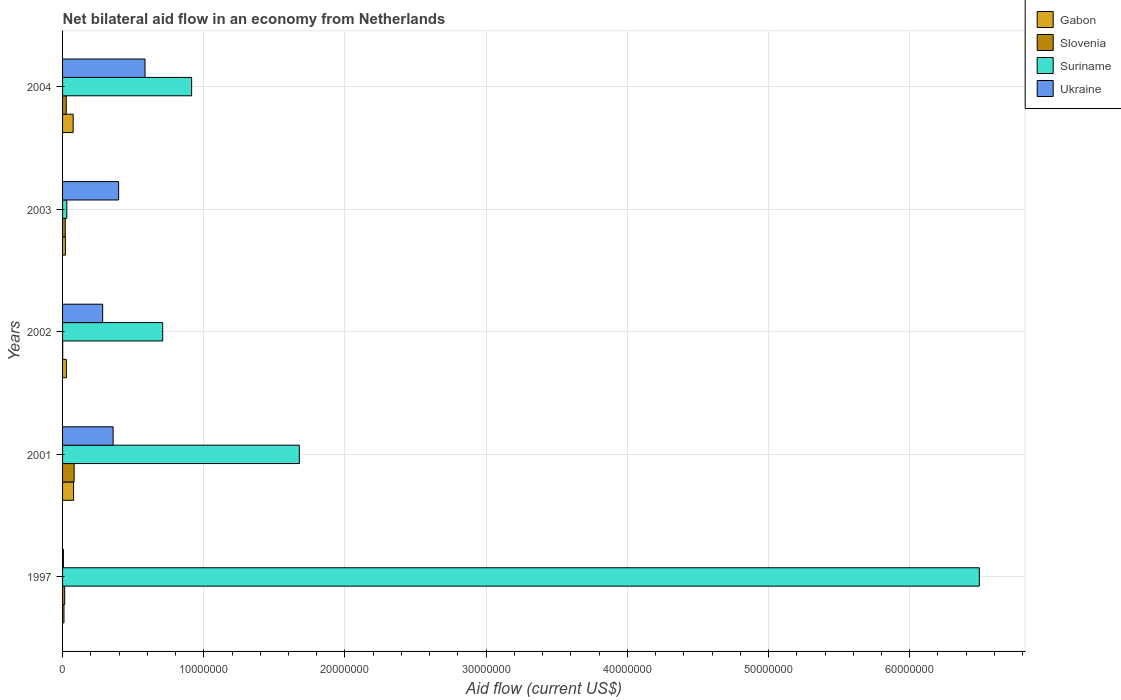How many groups of bars are there?
Your answer should be very brief. 5. Are the number of bars per tick equal to the number of legend labels?
Offer a terse response. Yes. How many bars are there on the 4th tick from the top?
Ensure brevity in your answer.  4. How many bars are there on the 2nd tick from the bottom?
Your answer should be very brief. 4. What is the label of the 3rd group of bars from the top?
Keep it short and to the point. 2002. What is the net bilateral aid flow in Gabon in 2001?
Provide a succinct answer. 7.80e+05. Across all years, what is the maximum net bilateral aid flow in Gabon?
Provide a succinct answer. 7.80e+05. In which year was the net bilateral aid flow in Slovenia minimum?
Keep it short and to the point. 2002. What is the total net bilateral aid flow in Suriname in the graph?
Ensure brevity in your answer.  9.82e+07. What is the difference between the net bilateral aid flow in Suriname in 2003 and that in 2004?
Give a very brief answer. -8.84e+06. What is the difference between the net bilateral aid flow in Gabon in 2004 and the net bilateral aid flow in Ukraine in 2003?
Make the answer very short. -3.22e+06. What is the average net bilateral aid flow in Suriname per year?
Provide a short and direct response. 1.96e+07. In the year 2002, what is the difference between the net bilateral aid flow in Ukraine and net bilateral aid flow in Suriname?
Your answer should be compact. -4.25e+06. What is the ratio of the net bilateral aid flow in Gabon in 2002 to that in 2003?
Make the answer very short. 1.35. Is the net bilateral aid flow in Ukraine in 1997 less than that in 2003?
Keep it short and to the point. Yes. What is the difference between the highest and the second highest net bilateral aid flow in Slovenia?
Your answer should be compact. 5.60e+05. What is the difference between the highest and the lowest net bilateral aid flow in Suriname?
Give a very brief answer. 6.46e+07. Is the sum of the net bilateral aid flow in Slovenia in 2001 and 2002 greater than the maximum net bilateral aid flow in Gabon across all years?
Offer a terse response. Yes. What does the 2nd bar from the top in 2003 represents?
Your response must be concise. Suriname. What does the 2nd bar from the bottom in 2001 represents?
Your answer should be very brief. Slovenia. What is the difference between two consecutive major ticks on the X-axis?
Offer a very short reply. 1.00e+07. Where does the legend appear in the graph?
Offer a very short reply. Top right. How many legend labels are there?
Make the answer very short. 4. How are the legend labels stacked?
Your answer should be compact. Vertical. What is the title of the graph?
Provide a succinct answer. Net bilateral aid flow in an economy from Netherlands. What is the label or title of the X-axis?
Keep it short and to the point. Aid flow (current US$). What is the Aid flow (current US$) in Gabon in 1997?
Provide a short and direct response. 1.00e+05. What is the Aid flow (current US$) in Suriname in 1997?
Keep it short and to the point. 6.49e+07. What is the Aid flow (current US$) of Ukraine in 1997?
Give a very brief answer. 6.00e+04. What is the Aid flow (current US$) of Gabon in 2001?
Your answer should be very brief. 7.80e+05. What is the Aid flow (current US$) in Slovenia in 2001?
Provide a succinct answer. 8.20e+05. What is the Aid flow (current US$) of Suriname in 2001?
Provide a short and direct response. 1.68e+07. What is the Aid flow (current US$) of Ukraine in 2001?
Your answer should be compact. 3.58e+06. What is the Aid flow (current US$) in Suriname in 2002?
Your response must be concise. 7.09e+06. What is the Aid flow (current US$) in Ukraine in 2002?
Give a very brief answer. 2.84e+06. What is the Aid flow (current US$) in Suriname in 2003?
Keep it short and to the point. 3.00e+05. What is the Aid flow (current US$) of Ukraine in 2003?
Ensure brevity in your answer.  3.97e+06. What is the Aid flow (current US$) of Gabon in 2004?
Give a very brief answer. 7.50e+05. What is the Aid flow (current US$) of Suriname in 2004?
Provide a short and direct response. 9.14e+06. What is the Aid flow (current US$) in Ukraine in 2004?
Give a very brief answer. 5.84e+06. Across all years, what is the maximum Aid flow (current US$) of Gabon?
Keep it short and to the point. 7.80e+05. Across all years, what is the maximum Aid flow (current US$) of Slovenia?
Provide a succinct answer. 8.20e+05. Across all years, what is the maximum Aid flow (current US$) in Suriname?
Make the answer very short. 6.49e+07. Across all years, what is the maximum Aid flow (current US$) of Ukraine?
Offer a terse response. 5.84e+06. Across all years, what is the minimum Aid flow (current US$) of Slovenia?
Provide a short and direct response. 10000. Across all years, what is the minimum Aid flow (current US$) in Suriname?
Give a very brief answer. 3.00e+05. Across all years, what is the minimum Aid flow (current US$) in Ukraine?
Offer a very short reply. 6.00e+04. What is the total Aid flow (current US$) of Gabon in the graph?
Provide a short and direct response. 2.10e+06. What is the total Aid flow (current US$) in Slovenia in the graph?
Offer a terse response. 1.43e+06. What is the total Aid flow (current US$) in Suriname in the graph?
Your answer should be very brief. 9.82e+07. What is the total Aid flow (current US$) in Ukraine in the graph?
Provide a succinct answer. 1.63e+07. What is the difference between the Aid flow (current US$) in Gabon in 1997 and that in 2001?
Your answer should be compact. -6.80e+05. What is the difference between the Aid flow (current US$) in Slovenia in 1997 and that in 2001?
Your answer should be very brief. -6.70e+05. What is the difference between the Aid flow (current US$) in Suriname in 1997 and that in 2001?
Offer a very short reply. 4.82e+07. What is the difference between the Aid flow (current US$) of Ukraine in 1997 and that in 2001?
Ensure brevity in your answer.  -3.52e+06. What is the difference between the Aid flow (current US$) of Slovenia in 1997 and that in 2002?
Your answer should be very brief. 1.40e+05. What is the difference between the Aid flow (current US$) of Suriname in 1997 and that in 2002?
Your answer should be very brief. 5.78e+07. What is the difference between the Aid flow (current US$) of Ukraine in 1997 and that in 2002?
Make the answer very short. -2.78e+06. What is the difference between the Aid flow (current US$) in Gabon in 1997 and that in 2003?
Offer a terse response. -1.00e+05. What is the difference between the Aid flow (current US$) of Suriname in 1997 and that in 2003?
Give a very brief answer. 6.46e+07. What is the difference between the Aid flow (current US$) of Ukraine in 1997 and that in 2003?
Make the answer very short. -3.91e+06. What is the difference between the Aid flow (current US$) in Gabon in 1997 and that in 2004?
Offer a very short reply. -6.50e+05. What is the difference between the Aid flow (current US$) of Slovenia in 1997 and that in 2004?
Provide a short and direct response. -1.10e+05. What is the difference between the Aid flow (current US$) in Suriname in 1997 and that in 2004?
Your response must be concise. 5.58e+07. What is the difference between the Aid flow (current US$) in Ukraine in 1997 and that in 2004?
Your response must be concise. -5.78e+06. What is the difference between the Aid flow (current US$) in Gabon in 2001 and that in 2002?
Ensure brevity in your answer.  5.10e+05. What is the difference between the Aid flow (current US$) in Slovenia in 2001 and that in 2002?
Your answer should be compact. 8.10e+05. What is the difference between the Aid flow (current US$) of Suriname in 2001 and that in 2002?
Your answer should be very brief. 9.68e+06. What is the difference between the Aid flow (current US$) of Ukraine in 2001 and that in 2002?
Your answer should be compact. 7.40e+05. What is the difference between the Aid flow (current US$) of Gabon in 2001 and that in 2003?
Your response must be concise. 5.80e+05. What is the difference between the Aid flow (current US$) in Slovenia in 2001 and that in 2003?
Ensure brevity in your answer.  6.30e+05. What is the difference between the Aid flow (current US$) of Suriname in 2001 and that in 2003?
Offer a very short reply. 1.65e+07. What is the difference between the Aid flow (current US$) in Ukraine in 2001 and that in 2003?
Ensure brevity in your answer.  -3.90e+05. What is the difference between the Aid flow (current US$) in Slovenia in 2001 and that in 2004?
Give a very brief answer. 5.60e+05. What is the difference between the Aid flow (current US$) in Suriname in 2001 and that in 2004?
Make the answer very short. 7.63e+06. What is the difference between the Aid flow (current US$) in Ukraine in 2001 and that in 2004?
Your answer should be very brief. -2.26e+06. What is the difference between the Aid flow (current US$) in Gabon in 2002 and that in 2003?
Offer a terse response. 7.00e+04. What is the difference between the Aid flow (current US$) of Slovenia in 2002 and that in 2003?
Provide a succinct answer. -1.80e+05. What is the difference between the Aid flow (current US$) of Suriname in 2002 and that in 2003?
Ensure brevity in your answer.  6.79e+06. What is the difference between the Aid flow (current US$) of Ukraine in 2002 and that in 2003?
Offer a very short reply. -1.13e+06. What is the difference between the Aid flow (current US$) in Gabon in 2002 and that in 2004?
Your answer should be very brief. -4.80e+05. What is the difference between the Aid flow (current US$) in Suriname in 2002 and that in 2004?
Offer a terse response. -2.05e+06. What is the difference between the Aid flow (current US$) in Gabon in 2003 and that in 2004?
Your answer should be very brief. -5.50e+05. What is the difference between the Aid flow (current US$) of Suriname in 2003 and that in 2004?
Offer a very short reply. -8.84e+06. What is the difference between the Aid flow (current US$) in Ukraine in 2003 and that in 2004?
Offer a very short reply. -1.87e+06. What is the difference between the Aid flow (current US$) of Gabon in 1997 and the Aid flow (current US$) of Slovenia in 2001?
Provide a succinct answer. -7.20e+05. What is the difference between the Aid flow (current US$) in Gabon in 1997 and the Aid flow (current US$) in Suriname in 2001?
Keep it short and to the point. -1.67e+07. What is the difference between the Aid flow (current US$) in Gabon in 1997 and the Aid flow (current US$) in Ukraine in 2001?
Offer a very short reply. -3.48e+06. What is the difference between the Aid flow (current US$) in Slovenia in 1997 and the Aid flow (current US$) in Suriname in 2001?
Your response must be concise. -1.66e+07. What is the difference between the Aid flow (current US$) of Slovenia in 1997 and the Aid flow (current US$) of Ukraine in 2001?
Your answer should be compact. -3.43e+06. What is the difference between the Aid flow (current US$) of Suriname in 1997 and the Aid flow (current US$) of Ukraine in 2001?
Offer a terse response. 6.14e+07. What is the difference between the Aid flow (current US$) of Gabon in 1997 and the Aid flow (current US$) of Slovenia in 2002?
Provide a short and direct response. 9.00e+04. What is the difference between the Aid flow (current US$) of Gabon in 1997 and the Aid flow (current US$) of Suriname in 2002?
Provide a succinct answer. -6.99e+06. What is the difference between the Aid flow (current US$) of Gabon in 1997 and the Aid flow (current US$) of Ukraine in 2002?
Give a very brief answer. -2.74e+06. What is the difference between the Aid flow (current US$) in Slovenia in 1997 and the Aid flow (current US$) in Suriname in 2002?
Give a very brief answer. -6.94e+06. What is the difference between the Aid flow (current US$) of Slovenia in 1997 and the Aid flow (current US$) of Ukraine in 2002?
Offer a terse response. -2.69e+06. What is the difference between the Aid flow (current US$) of Suriname in 1997 and the Aid flow (current US$) of Ukraine in 2002?
Provide a succinct answer. 6.21e+07. What is the difference between the Aid flow (current US$) in Gabon in 1997 and the Aid flow (current US$) in Slovenia in 2003?
Give a very brief answer. -9.00e+04. What is the difference between the Aid flow (current US$) in Gabon in 1997 and the Aid flow (current US$) in Suriname in 2003?
Offer a very short reply. -2.00e+05. What is the difference between the Aid flow (current US$) of Gabon in 1997 and the Aid flow (current US$) of Ukraine in 2003?
Your answer should be very brief. -3.87e+06. What is the difference between the Aid flow (current US$) of Slovenia in 1997 and the Aid flow (current US$) of Suriname in 2003?
Your answer should be very brief. -1.50e+05. What is the difference between the Aid flow (current US$) of Slovenia in 1997 and the Aid flow (current US$) of Ukraine in 2003?
Give a very brief answer. -3.82e+06. What is the difference between the Aid flow (current US$) in Suriname in 1997 and the Aid flow (current US$) in Ukraine in 2003?
Offer a very short reply. 6.10e+07. What is the difference between the Aid flow (current US$) in Gabon in 1997 and the Aid flow (current US$) in Slovenia in 2004?
Provide a succinct answer. -1.60e+05. What is the difference between the Aid flow (current US$) in Gabon in 1997 and the Aid flow (current US$) in Suriname in 2004?
Provide a short and direct response. -9.04e+06. What is the difference between the Aid flow (current US$) in Gabon in 1997 and the Aid flow (current US$) in Ukraine in 2004?
Provide a succinct answer. -5.74e+06. What is the difference between the Aid flow (current US$) of Slovenia in 1997 and the Aid flow (current US$) of Suriname in 2004?
Make the answer very short. -8.99e+06. What is the difference between the Aid flow (current US$) in Slovenia in 1997 and the Aid flow (current US$) in Ukraine in 2004?
Your answer should be very brief. -5.69e+06. What is the difference between the Aid flow (current US$) in Suriname in 1997 and the Aid flow (current US$) in Ukraine in 2004?
Give a very brief answer. 5.91e+07. What is the difference between the Aid flow (current US$) in Gabon in 2001 and the Aid flow (current US$) in Slovenia in 2002?
Your answer should be compact. 7.70e+05. What is the difference between the Aid flow (current US$) in Gabon in 2001 and the Aid flow (current US$) in Suriname in 2002?
Ensure brevity in your answer.  -6.31e+06. What is the difference between the Aid flow (current US$) of Gabon in 2001 and the Aid flow (current US$) of Ukraine in 2002?
Offer a terse response. -2.06e+06. What is the difference between the Aid flow (current US$) in Slovenia in 2001 and the Aid flow (current US$) in Suriname in 2002?
Give a very brief answer. -6.27e+06. What is the difference between the Aid flow (current US$) of Slovenia in 2001 and the Aid flow (current US$) of Ukraine in 2002?
Provide a succinct answer. -2.02e+06. What is the difference between the Aid flow (current US$) of Suriname in 2001 and the Aid flow (current US$) of Ukraine in 2002?
Keep it short and to the point. 1.39e+07. What is the difference between the Aid flow (current US$) of Gabon in 2001 and the Aid flow (current US$) of Slovenia in 2003?
Offer a terse response. 5.90e+05. What is the difference between the Aid flow (current US$) of Gabon in 2001 and the Aid flow (current US$) of Suriname in 2003?
Provide a short and direct response. 4.80e+05. What is the difference between the Aid flow (current US$) in Gabon in 2001 and the Aid flow (current US$) in Ukraine in 2003?
Provide a succinct answer. -3.19e+06. What is the difference between the Aid flow (current US$) in Slovenia in 2001 and the Aid flow (current US$) in Suriname in 2003?
Your answer should be very brief. 5.20e+05. What is the difference between the Aid flow (current US$) in Slovenia in 2001 and the Aid flow (current US$) in Ukraine in 2003?
Your response must be concise. -3.15e+06. What is the difference between the Aid flow (current US$) in Suriname in 2001 and the Aid flow (current US$) in Ukraine in 2003?
Ensure brevity in your answer.  1.28e+07. What is the difference between the Aid flow (current US$) of Gabon in 2001 and the Aid flow (current US$) of Slovenia in 2004?
Your answer should be very brief. 5.20e+05. What is the difference between the Aid flow (current US$) of Gabon in 2001 and the Aid flow (current US$) of Suriname in 2004?
Your response must be concise. -8.36e+06. What is the difference between the Aid flow (current US$) of Gabon in 2001 and the Aid flow (current US$) of Ukraine in 2004?
Your response must be concise. -5.06e+06. What is the difference between the Aid flow (current US$) in Slovenia in 2001 and the Aid flow (current US$) in Suriname in 2004?
Your answer should be very brief. -8.32e+06. What is the difference between the Aid flow (current US$) in Slovenia in 2001 and the Aid flow (current US$) in Ukraine in 2004?
Your answer should be compact. -5.02e+06. What is the difference between the Aid flow (current US$) of Suriname in 2001 and the Aid flow (current US$) of Ukraine in 2004?
Provide a succinct answer. 1.09e+07. What is the difference between the Aid flow (current US$) in Gabon in 2002 and the Aid flow (current US$) in Ukraine in 2003?
Keep it short and to the point. -3.70e+06. What is the difference between the Aid flow (current US$) in Slovenia in 2002 and the Aid flow (current US$) in Suriname in 2003?
Your answer should be very brief. -2.90e+05. What is the difference between the Aid flow (current US$) in Slovenia in 2002 and the Aid flow (current US$) in Ukraine in 2003?
Provide a short and direct response. -3.96e+06. What is the difference between the Aid flow (current US$) of Suriname in 2002 and the Aid flow (current US$) of Ukraine in 2003?
Your answer should be compact. 3.12e+06. What is the difference between the Aid flow (current US$) of Gabon in 2002 and the Aid flow (current US$) of Suriname in 2004?
Keep it short and to the point. -8.87e+06. What is the difference between the Aid flow (current US$) of Gabon in 2002 and the Aid flow (current US$) of Ukraine in 2004?
Provide a succinct answer. -5.57e+06. What is the difference between the Aid flow (current US$) of Slovenia in 2002 and the Aid flow (current US$) of Suriname in 2004?
Make the answer very short. -9.13e+06. What is the difference between the Aid flow (current US$) in Slovenia in 2002 and the Aid flow (current US$) in Ukraine in 2004?
Ensure brevity in your answer.  -5.83e+06. What is the difference between the Aid flow (current US$) in Suriname in 2002 and the Aid flow (current US$) in Ukraine in 2004?
Provide a short and direct response. 1.25e+06. What is the difference between the Aid flow (current US$) of Gabon in 2003 and the Aid flow (current US$) of Suriname in 2004?
Your answer should be compact. -8.94e+06. What is the difference between the Aid flow (current US$) of Gabon in 2003 and the Aid flow (current US$) of Ukraine in 2004?
Provide a short and direct response. -5.64e+06. What is the difference between the Aid flow (current US$) in Slovenia in 2003 and the Aid flow (current US$) in Suriname in 2004?
Your answer should be very brief. -8.95e+06. What is the difference between the Aid flow (current US$) in Slovenia in 2003 and the Aid flow (current US$) in Ukraine in 2004?
Keep it short and to the point. -5.65e+06. What is the difference between the Aid flow (current US$) in Suriname in 2003 and the Aid flow (current US$) in Ukraine in 2004?
Your answer should be very brief. -5.54e+06. What is the average Aid flow (current US$) of Slovenia per year?
Keep it short and to the point. 2.86e+05. What is the average Aid flow (current US$) of Suriname per year?
Your answer should be compact. 1.96e+07. What is the average Aid flow (current US$) of Ukraine per year?
Your answer should be compact. 3.26e+06. In the year 1997, what is the difference between the Aid flow (current US$) of Gabon and Aid flow (current US$) of Suriname?
Make the answer very short. -6.48e+07. In the year 1997, what is the difference between the Aid flow (current US$) in Slovenia and Aid flow (current US$) in Suriname?
Ensure brevity in your answer.  -6.48e+07. In the year 1997, what is the difference between the Aid flow (current US$) in Slovenia and Aid flow (current US$) in Ukraine?
Give a very brief answer. 9.00e+04. In the year 1997, what is the difference between the Aid flow (current US$) of Suriname and Aid flow (current US$) of Ukraine?
Give a very brief answer. 6.49e+07. In the year 2001, what is the difference between the Aid flow (current US$) in Gabon and Aid flow (current US$) in Slovenia?
Ensure brevity in your answer.  -4.00e+04. In the year 2001, what is the difference between the Aid flow (current US$) of Gabon and Aid flow (current US$) of Suriname?
Your answer should be compact. -1.60e+07. In the year 2001, what is the difference between the Aid flow (current US$) in Gabon and Aid flow (current US$) in Ukraine?
Offer a very short reply. -2.80e+06. In the year 2001, what is the difference between the Aid flow (current US$) in Slovenia and Aid flow (current US$) in Suriname?
Keep it short and to the point. -1.60e+07. In the year 2001, what is the difference between the Aid flow (current US$) in Slovenia and Aid flow (current US$) in Ukraine?
Provide a succinct answer. -2.76e+06. In the year 2001, what is the difference between the Aid flow (current US$) of Suriname and Aid flow (current US$) of Ukraine?
Ensure brevity in your answer.  1.32e+07. In the year 2002, what is the difference between the Aid flow (current US$) of Gabon and Aid flow (current US$) of Suriname?
Offer a terse response. -6.82e+06. In the year 2002, what is the difference between the Aid flow (current US$) in Gabon and Aid flow (current US$) in Ukraine?
Offer a terse response. -2.57e+06. In the year 2002, what is the difference between the Aid flow (current US$) of Slovenia and Aid flow (current US$) of Suriname?
Provide a short and direct response. -7.08e+06. In the year 2002, what is the difference between the Aid flow (current US$) of Slovenia and Aid flow (current US$) of Ukraine?
Make the answer very short. -2.83e+06. In the year 2002, what is the difference between the Aid flow (current US$) in Suriname and Aid flow (current US$) in Ukraine?
Offer a very short reply. 4.25e+06. In the year 2003, what is the difference between the Aid flow (current US$) in Gabon and Aid flow (current US$) in Slovenia?
Ensure brevity in your answer.  10000. In the year 2003, what is the difference between the Aid flow (current US$) in Gabon and Aid flow (current US$) in Ukraine?
Your answer should be compact. -3.77e+06. In the year 2003, what is the difference between the Aid flow (current US$) of Slovenia and Aid flow (current US$) of Ukraine?
Ensure brevity in your answer.  -3.78e+06. In the year 2003, what is the difference between the Aid flow (current US$) in Suriname and Aid flow (current US$) in Ukraine?
Provide a succinct answer. -3.67e+06. In the year 2004, what is the difference between the Aid flow (current US$) in Gabon and Aid flow (current US$) in Suriname?
Provide a short and direct response. -8.39e+06. In the year 2004, what is the difference between the Aid flow (current US$) in Gabon and Aid flow (current US$) in Ukraine?
Offer a terse response. -5.09e+06. In the year 2004, what is the difference between the Aid flow (current US$) in Slovenia and Aid flow (current US$) in Suriname?
Make the answer very short. -8.88e+06. In the year 2004, what is the difference between the Aid flow (current US$) of Slovenia and Aid flow (current US$) of Ukraine?
Offer a very short reply. -5.58e+06. In the year 2004, what is the difference between the Aid flow (current US$) in Suriname and Aid flow (current US$) in Ukraine?
Offer a very short reply. 3.30e+06. What is the ratio of the Aid flow (current US$) of Gabon in 1997 to that in 2001?
Offer a very short reply. 0.13. What is the ratio of the Aid flow (current US$) of Slovenia in 1997 to that in 2001?
Make the answer very short. 0.18. What is the ratio of the Aid flow (current US$) of Suriname in 1997 to that in 2001?
Your answer should be very brief. 3.87. What is the ratio of the Aid flow (current US$) of Ukraine in 1997 to that in 2001?
Offer a terse response. 0.02. What is the ratio of the Aid flow (current US$) in Gabon in 1997 to that in 2002?
Give a very brief answer. 0.37. What is the ratio of the Aid flow (current US$) of Slovenia in 1997 to that in 2002?
Ensure brevity in your answer.  15. What is the ratio of the Aid flow (current US$) of Suriname in 1997 to that in 2002?
Your response must be concise. 9.16. What is the ratio of the Aid flow (current US$) in Ukraine in 1997 to that in 2002?
Ensure brevity in your answer.  0.02. What is the ratio of the Aid flow (current US$) in Gabon in 1997 to that in 2003?
Keep it short and to the point. 0.5. What is the ratio of the Aid flow (current US$) in Slovenia in 1997 to that in 2003?
Keep it short and to the point. 0.79. What is the ratio of the Aid flow (current US$) in Suriname in 1997 to that in 2003?
Your response must be concise. 216.43. What is the ratio of the Aid flow (current US$) in Ukraine in 1997 to that in 2003?
Your answer should be very brief. 0.02. What is the ratio of the Aid flow (current US$) of Gabon in 1997 to that in 2004?
Your answer should be compact. 0.13. What is the ratio of the Aid flow (current US$) of Slovenia in 1997 to that in 2004?
Your response must be concise. 0.58. What is the ratio of the Aid flow (current US$) in Suriname in 1997 to that in 2004?
Offer a terse response. 7.1. What is the ratio of the Aid flow (current US$) in Ukraine in 1997 to that in 2004?
Provide a succinct answer. 0.01. What is the ratio of the Aid flow (current US$) in Gabon in 2001 to that in 2002?
Keep it short and to the point. 2.89. What is the ratio of the Aid flow (current US$) of Suriname in 2001 to that in 2002?
Give a very brief answer. 2.37. What is the ratio of the Aid flow (current US$) of Ukraine in 2001 to that in 2002?
Provide a succinct answer. 1.26. What is the ratio of the Aid flow (current US$) of Slovenia in 2001 to that in 2003?
Provide a short and direct response. 4.32. What is the ratio of the Aid flow (current US$) of Suriname in 2001 to that in 2003?
Provide a succinct answer. 55.9. What is the ratio of the Aid flow (current US$) in Ukraine in 2001 to that in 2003?
Ensure brevity in your answer.  0.9. What is the ratio of the Aid flow (current US$) of Slovenia in 2001 to that in 2004?
Offer a very short reply. 3.15. What is the ratio of the Aid flow (current US$) of Suriname in 2001 to that in 2004?
Offer a very short reply. 1.83. What is the ratio of the Aid flow (current US$) of Ukraine in 2001 to that in 2004?
Your response must be concise. 0.61. What is the ratio of the Aid flow (current US$) in Gabon in 2002 to that in 2003?
Ensure brevity in your answer.  1.35. What is the ratio of the Aid flow (current US$) of Slovenia in 2002 to that in 2003?
Your response must be concise. 0.05. What is the ratio of the Aid flow (current US$) in Suriname in 2002 to that in 2003?
Your response must be concise. 23.63. What is the ratio of the Aid flow (current US$) of Ukraine in 2002 to that in 2003?
Your response must be concise. 0.72. What is the ratio of the Aid flow (current US$) in Gabon in 2002 to that in 2004?
Offer a terse response. 0.36. What is the ratio of the Aid flow (current US$) in Slovenia in 2002 to that in 2004?
Give a very brief answer. 0.04. What is the ratio of the Aid flow (current US$) of Suriname in 2002 to that in 2004?
Keep it short and to the point. 0.78. What is the ratio of the Aid flow (current US$) in Ukraine in 2002 to that in 2004?
Keep it short and to the point. 0.49. What is the ratio of the Aid flow (current US$) of Gabon in 2003 to that in 2004?
Your answer should be compact. 0.27. What is the ratio of the Aid flow (current US$) of Slovenia in 2003 to that in 2004?
Your response must be concise. 0.73. What is the ratio of the Aid flow (current US$) in Suriname in 2003 to that in 2004?
Make the answer very short. 0.03. What is the ratio of the Aid flow (current US$) in Ukraine in 2003 to that in 2004?
Keep it short and to the point. 0.68. What is the difference between the highest and the second highest Aid flow (current US$) of Gabon?
Make the answer very short. 3.00e+04. What is the difference between the highest and the second highest Aid flow (current US$) of Slovenia?
Keep it short and to the point. 5.60e+05. What is the difference between the highest and the second highest Aid flow (current US$) of Suriname?
Provide a short and direct response. 4.82e+07. What is the difference between the highest and the second highest Aid flow (current US$) of Ukraine?
Give a very brief answer. 1.87e+06. What is the difference between the highest and the lowest Aid flow (current US$) in Gabon?
Ensure brevity in your answer.  6.80e+05. What is the difference between the highest and the lowest Aid flow (current US$) of Slovenia?
Offer a very short reply. 8.10e+05. What is the difference between the highest and the lowest Aid flow (current US$) of Suriname?
Offer a very short reply. 6.46e+07. What is the difference between the highest and the lowest Aid flow (current US$) of Ukraine?
Give a very brief answer. 5.78e+06. 